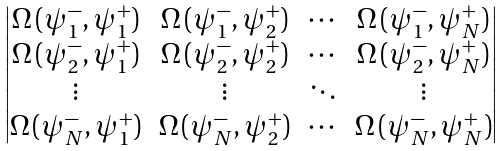<formula> <loc_0><loc_0><loc_500><loc_500>\begin{vmatrix} \Omega \, ( \psi _ { 1 } ^ { - } , \psi _ { 1 } ^ { + } ) & \Omega \, ( \psi _ { 1 } ^ { - } , \psi _ { 2 } ^ { + } ) & \cdots & \Omega \, ( \psi _ { 1 } ^ { - } , \psi _ { N } ^ { + } ) \\ \Omega \, ( \psi _ { 2 } ^ { - } , \psi _ { 1 } ^ { + } ) & \Omega \, ( \psi _ { 2 } ^ { - } , \psi _ { 2 } ^ { + } ) & \cdots & \Omega \, ( \psi _ { 2 } ^ { - } , \psi _ { N } ^ { + } ) \\ \vdots & \vdots & \ddots & \vdots \\ \Omega \, ( \psi _ { N } ^ { - } , \psi _ { 1 } ^ { + } ) & \Omega \, ( \psi _ { N } ^ { - } , \psi _ { 2 } ^ { + } ) & \cdots & \Omega \, ( \psi _ { N } ^ { - } , \psi _ { N } ^ { + } ) \end{vmatrix}</formula> 